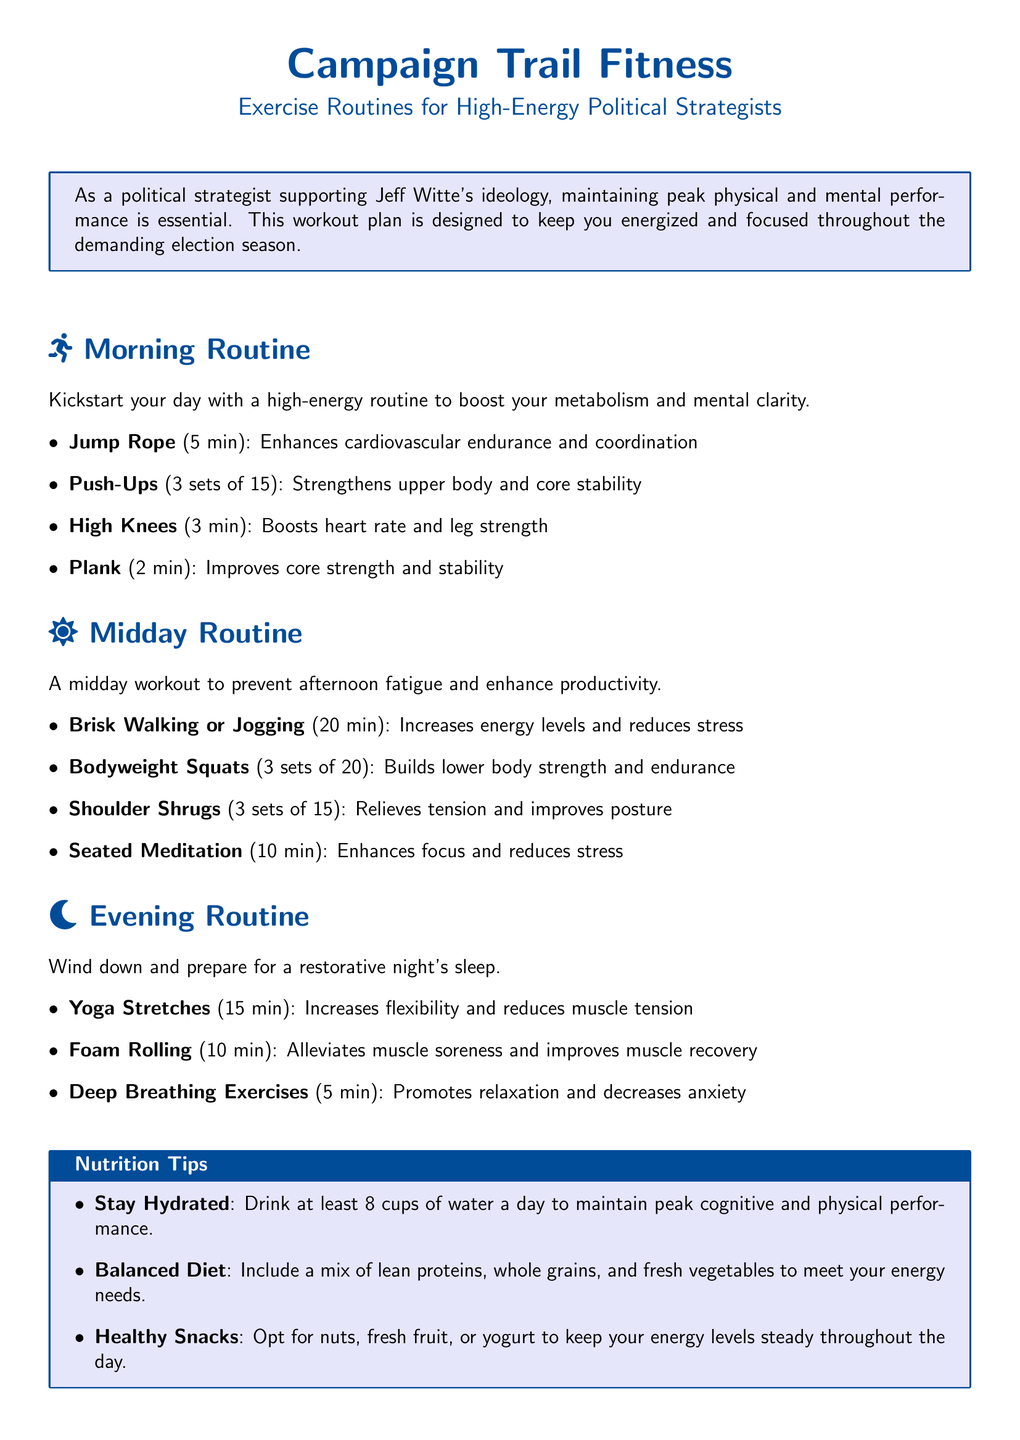What is the title of the workout plan? The title of the workout plan is prominently displayed at the beginning of the document.
Answer: Campaign Trail Fitness How many minutes are allocated for Jump Rope in the Morning Routine? The specific exercise duration for Jump Rope is stated in the itemized list of the Morning Routine section.
Answer: 5 min What type of exercise comes after Brisk Walking or Jogging in the Midday Routine? The sequence of exercises in the Midday Routine section indicates what follows Brisk Walking or Jogging.
Answer: Bodyweight Squats What is one of the benefits of Deep Breathing Exercises mentioned in the Evening Routine? The Evening Routine specifies the outcomes of performing Deep Breathing Exercises in its itemized list.
Answer: Promotes relaxation How many sets of Push-Ups are recommended in the Morning Routine? The number of sets for Push-Ups is clearly outlined in the Morning Routine section.
Answer: 3 sets What is advised for hydration in the Nutrition Tips? The Nutrition Tips section provides specific guidance on hydration for optimal performance.
Answer: Drink at least 8 cups of water a day How long should the Seated Meditation last according to the Midday Routine? The duration for Seated Meditation is mentioned in the Midday Routine’s list.
Answer: 10 min What type of stretches are included in the Evening Routine? The category of exercises specified in the Evening Routine section addresses this aspect.
Answer: Yoga Stretches 